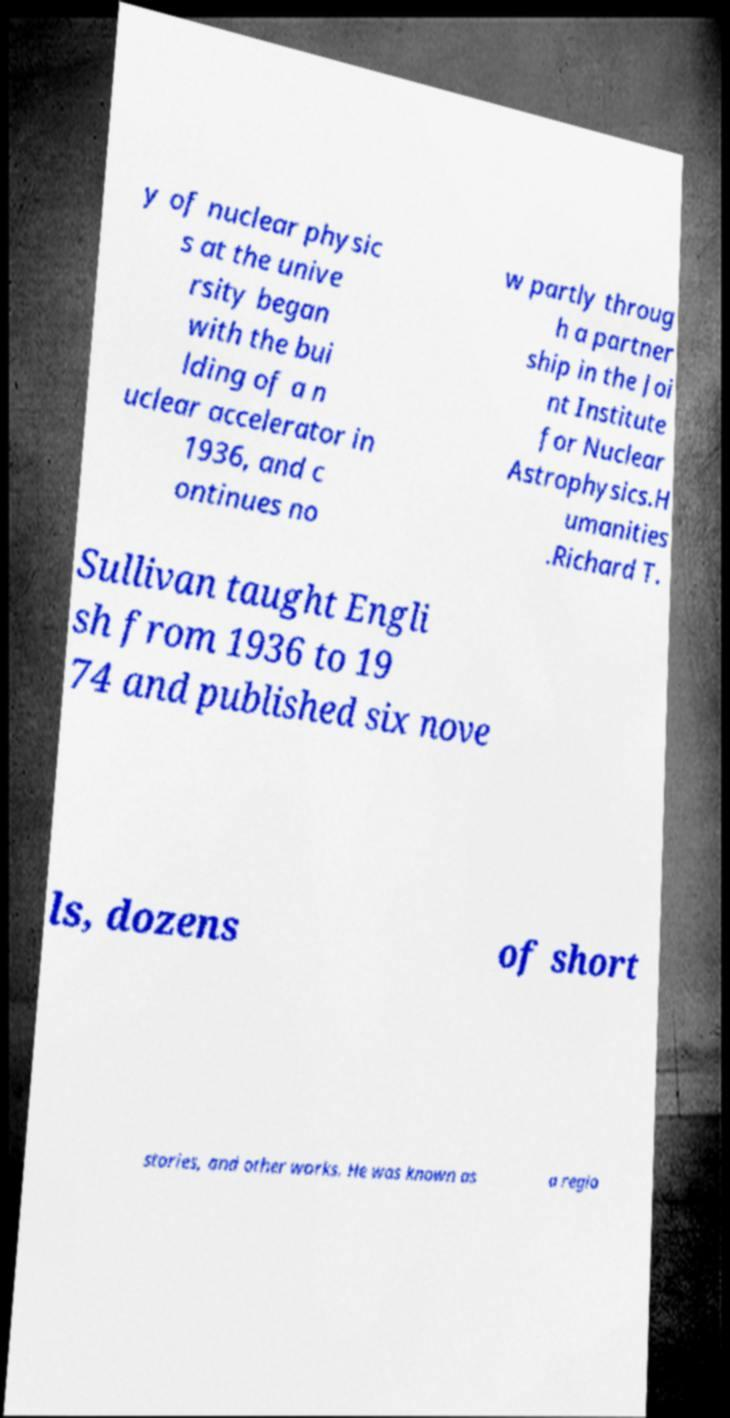Please identify and transcribe the text found in this image. y of nuclear physic s at the unive rsity began with the bui lding of a n uclear accelerator in 1936, and c ontinues no w partly throug h a partner ship in the Joi nt Institute for Nuclear Astrophysics.H umanities .Richard T. Sullivan taught Engli sh from 1936 to 19 74 and published six nove ls, dozens of short stories, and other works. He was known as a regio 